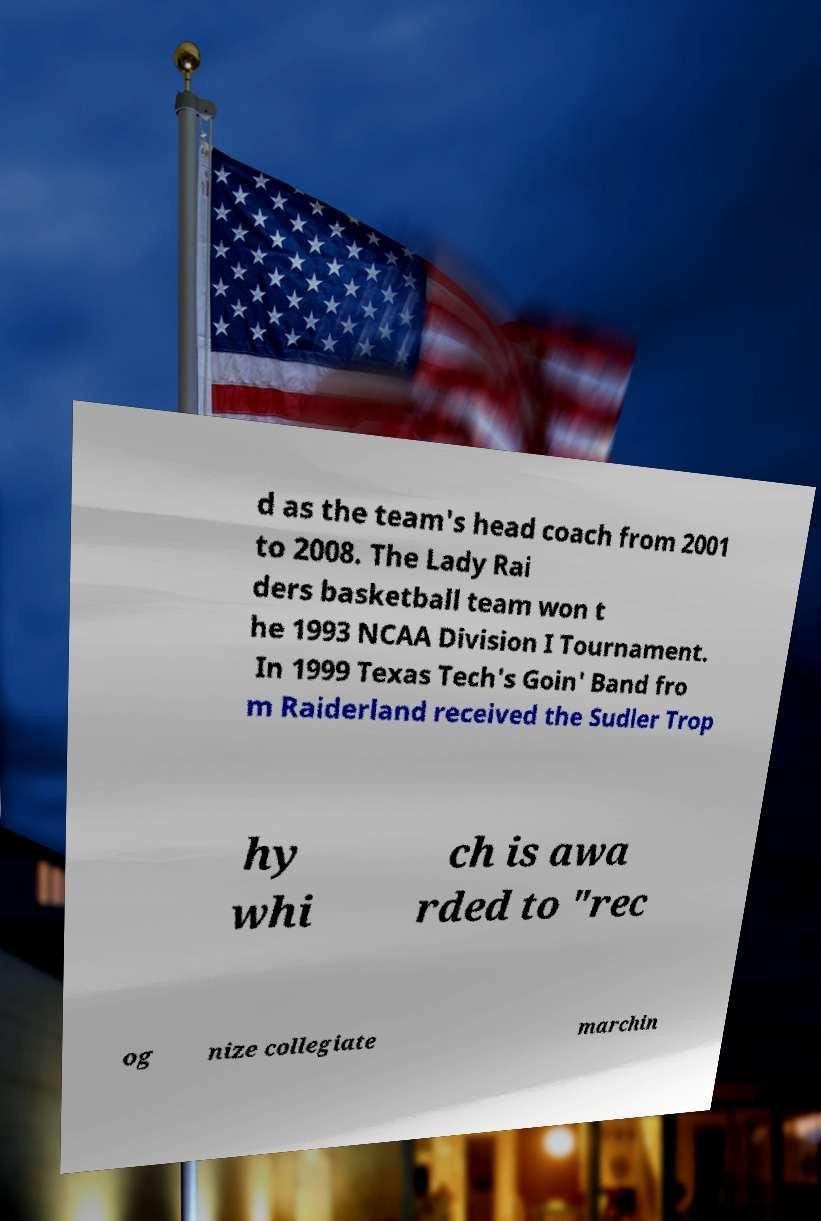I need the written content from this picture converted into text. Can you do that? d as the team's head coach from 2001 to 2008. The Lady Rai ders basketball team won t he 1993 NCAA Division I Tournament. In 1999 Texas Tech's Goin' Band fro m Raiderland received the Sudler Trop hy whi ch is awa rded to "rec og nize collegiate marchin 